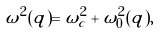<formula> <loc_0><loc_0><loc_500><loc_500>\omega ^ { 2 } ( q ) = \omega ^ { 2 } _ { c } + \omega ^ { 2 } _ { 0 } ( q ) ,</formula> 